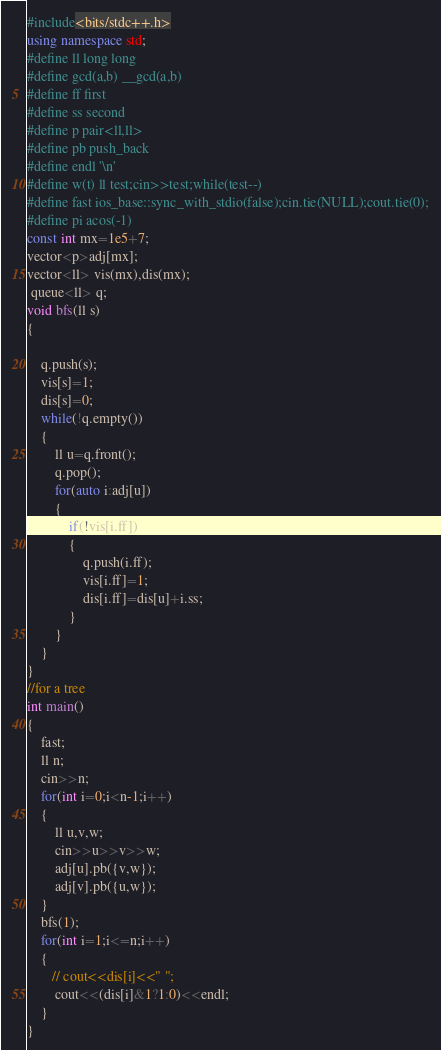Convert code to text. <code><loc_0><loc_0><loc_500><loc_500><_C++_>#include<bits/stdc++.h>
using namespace std;
#define ll long long
#define gcd(a,b) __gcd(a,b)
#define ff first
#define ss second
#define p pair<ll,ll>
#define pb push_back
#define endl '\n'
#define w(t) ll test;cin>>test;while(test--)
#define fast ios_base::sync_with_stdio(false);cin.tie(NULL);cout.tie(0);
#define pi acos(-1)
const int mx=1e5+7;
vector<p>adj[mx];
vector<ll> vis(mx),dis(mx);
 queue<ll> q;
void bfs(ll s)
{

    q.push(s);
    vis[s]=1;
    dis[s]=0;
    while(!q.empty())
    {
        ll u=q.front();
        q.pop();
        for(auto i:adj[u])
        {
            if(!vis[i.ff])
            {
                q.push(i.ff);
                vis[i.ff]=1;
                dis[i.ff]=dis[u]+i.ss;
            }
        }
    }
}
//for a tree
int main()
{
    fast;
    ll n;
    cin>>n;
    for(int i=0;i<n-1;i++)
    {
        ll u,v,w;
        cin>>u>>v>>w;
        adj[u].pb({v,w});
        adj[v].pb({u,w});
    }
    bfs(1);
    for(int i=1;i<=n;i++)
    {
       // cout<<dis[i]<<" ";
        cout<<(dis[i]&1?1:0)<<endl;
    }
}
</code> 